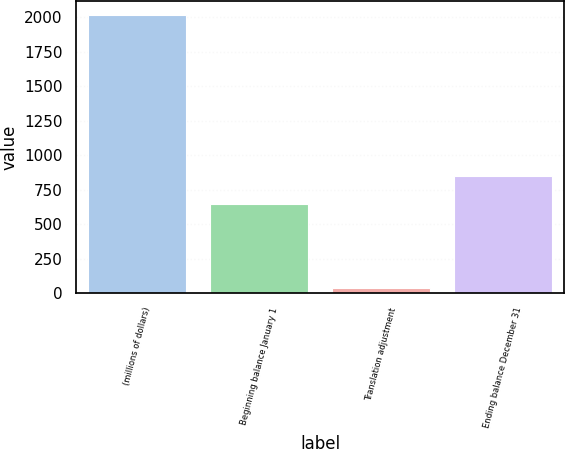<chart> <loc_0><loc_0><loc_500><loc_500><bar_chart><fcel>(millions of dollars)<fcel>Beginning balance January 1<fcel>Translation adjustment<fcel>Ending balance December 31<nl><fcel>2017<fcel>649.6<fcel>40.3<fcel>847.27<nl></chart> 